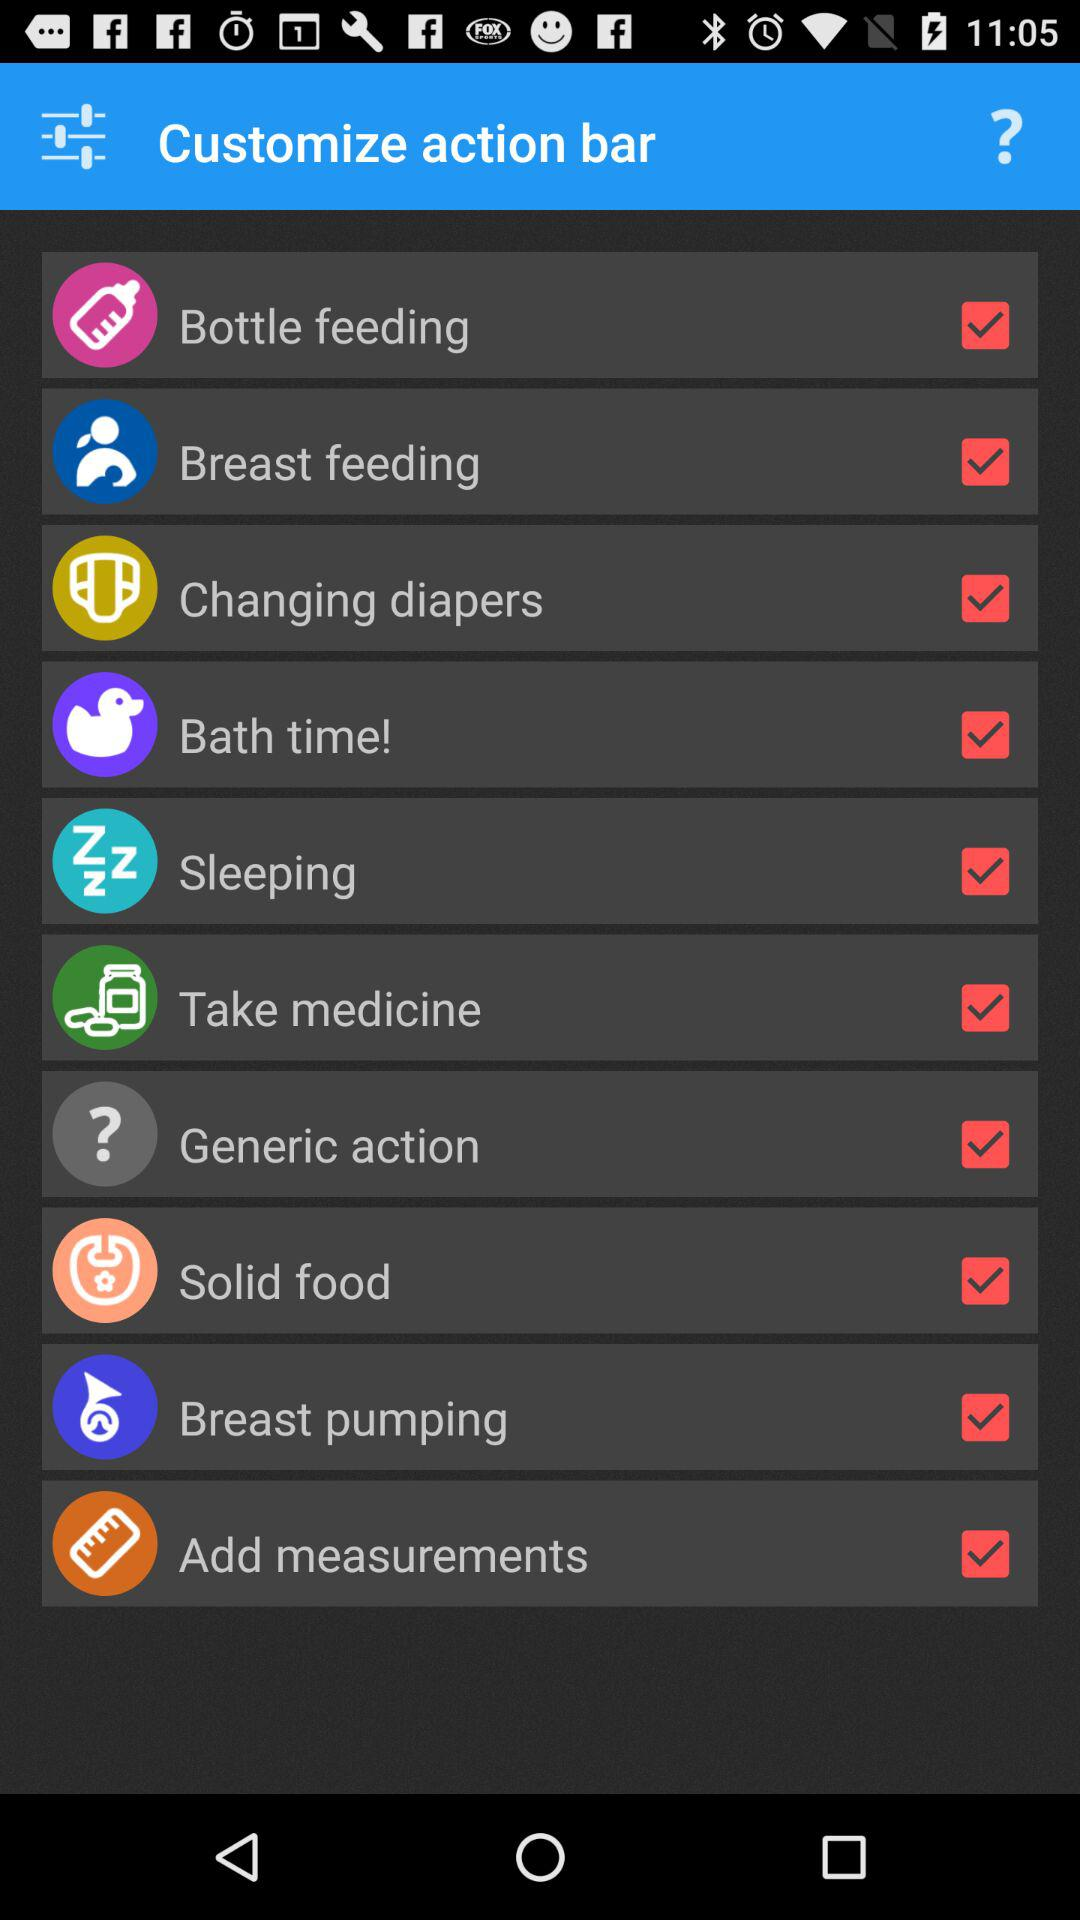What is the status of "sleeping"? The status is "on". 